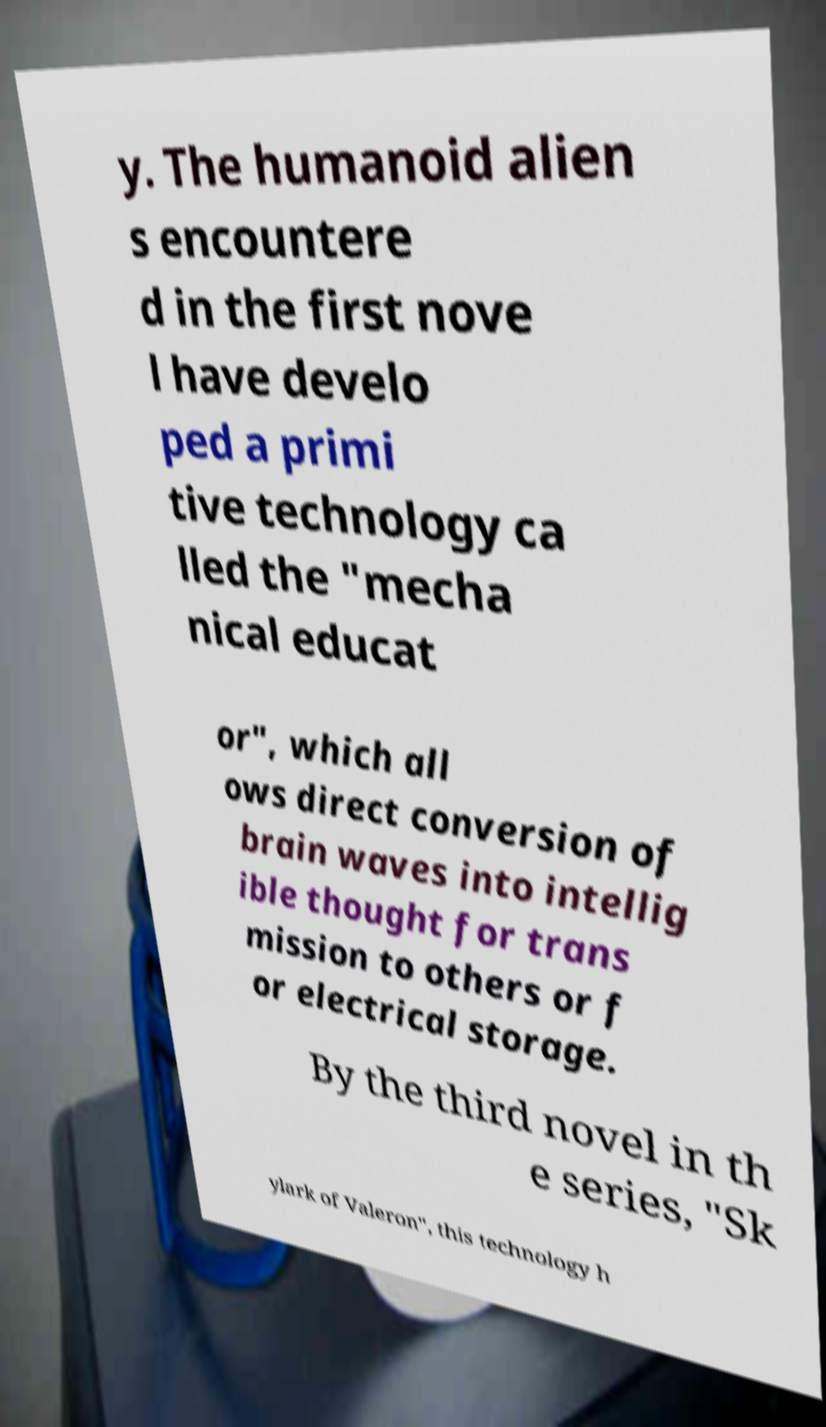Please identify and transcribe the text found in this image. y. The humanoid alien s encountere d in the first nove l have develo ped a primi tive technology ca lled the "mecha nical educat or", which all ows direct conversion of brain waves into intellig ible thought for trans mission to others or f or electrical storage. By the third novel in th e series, "Sk ylark of Valeron", this technology h 